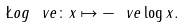<formula> <loc_0><loc_0><loc_500><loc_500>\L o g _ { \ } v e \colon x \mapsto - \ v e \log x .</formula> 